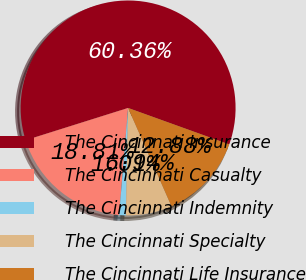Convert chart. <chart><loc_0><loc_0><loc_500><loc_500><pie_chart><fcel>The Cincinnati Insurance<fcel>The Cincinnati Casualty<fcel>The Cincinnati Indemnity<fcel>The Cincinnati Specialty<fcel>The Cincinnati Life Insurance<nl><fcel>60.36%<fcel>18.81%<fcel>1.01%<fcel>6.94%<fcel>12.88%<nl></chart> 